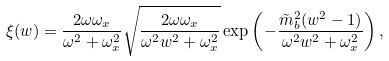Convert formula to latex. <formula><loc_0><loc_0><loc_500><loc_500>\xi ( w ) = \frac { 2 \omega \omega _ { x } } { \omega ^ { 2 } + \omega _ { x } ^ { 2 } } \sqrt { \frac { 2 \omega \omega _ { x } } { \omega ^ { 2 } w ^ { 2 } + \omega _ { x } ^ { 2 } } } \exp \left ( { - \frac { \tilde { m } _ { b } ^ { 2 } ( w ^ { 2 } - 1 ) } { \omega ^ { 2 } w ^ { 2 } + \omega _ { x } ^ { 2 } } } \right ) ,</formula> 